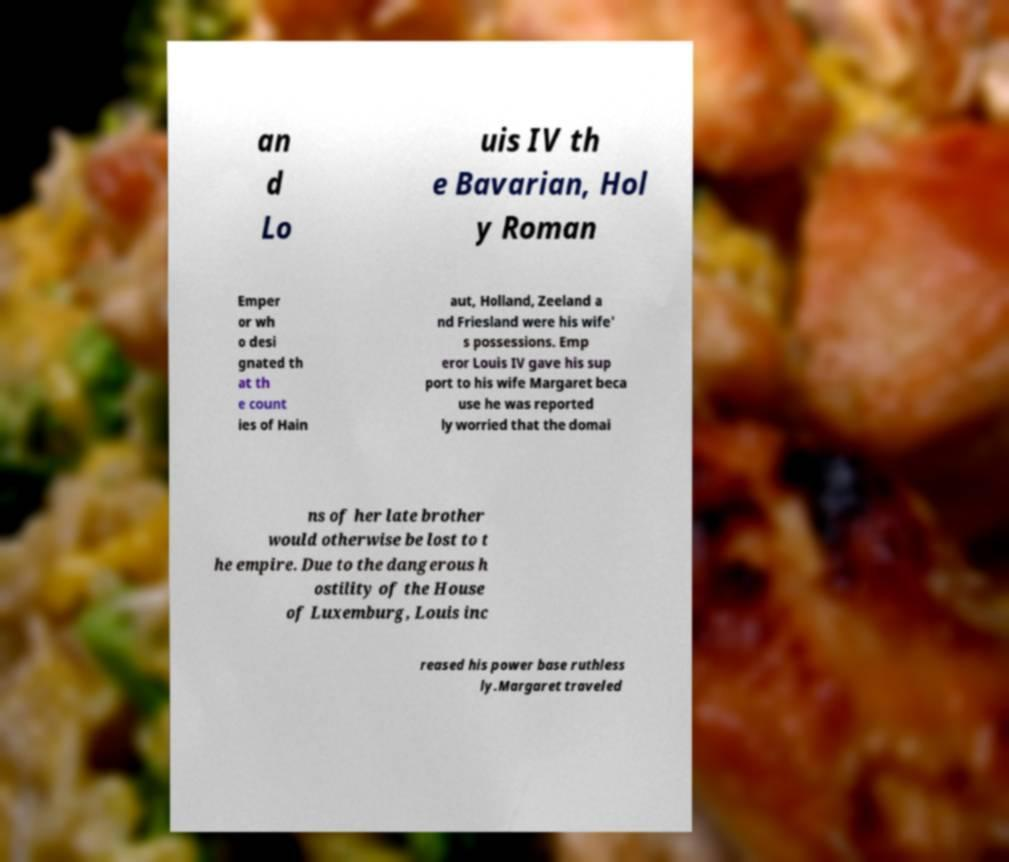Please identify and transcribe the text found in this image. an d Lo uis IV th e Bavarian, Hol y Roman Emper or wh o desi gnated th at th e count ies of Hain aut, Holland, Zeeland a nd Friesland were his wife' s possessions. Emp eror Louis IV gave his sup port to his wife Margaret beca use he was reported ly worried that the domai ns of her late brother would otherwise be lost to t he empire. Due to the dangerous h ostility of the House of Luxemburg, Louis inc reased his power base ruthless ly.Margaret traveled 